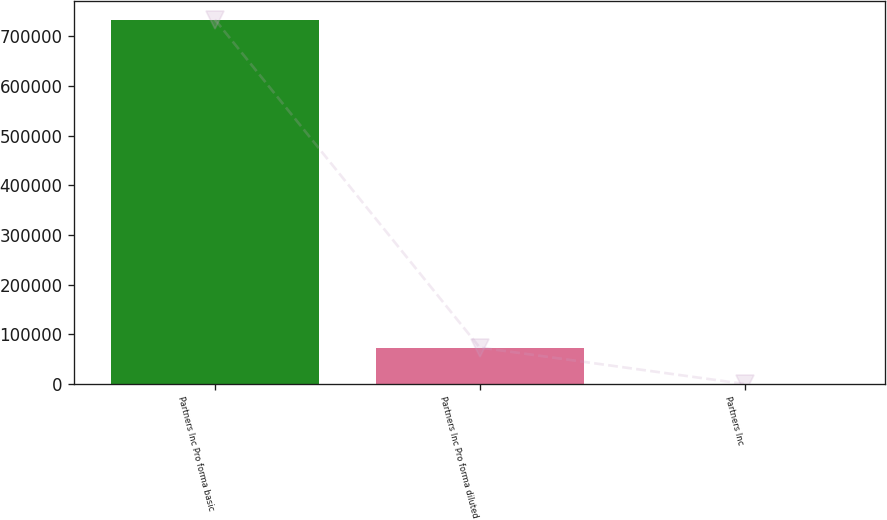Convert chart to OTSL. <chart><loc_0><loc_0><loc_500><loc_500><bar_chart><fcel>Partners Inc Pro forma basic<fcel>Partners Inc Pro forma diluted<fcel>Partners Inc<nl><fcel>733490<fcel>73352<fcel>3.38<nl></chart> 